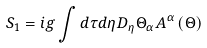<formula> <loc_0><loc_0><loc_500><loc_500>S _ { 1 } = i g \int d \tau d \eta D _ { \eta } \Theta _ { \alpha } A ^ { \alpha } \left ( \Theta \right )</formula> 